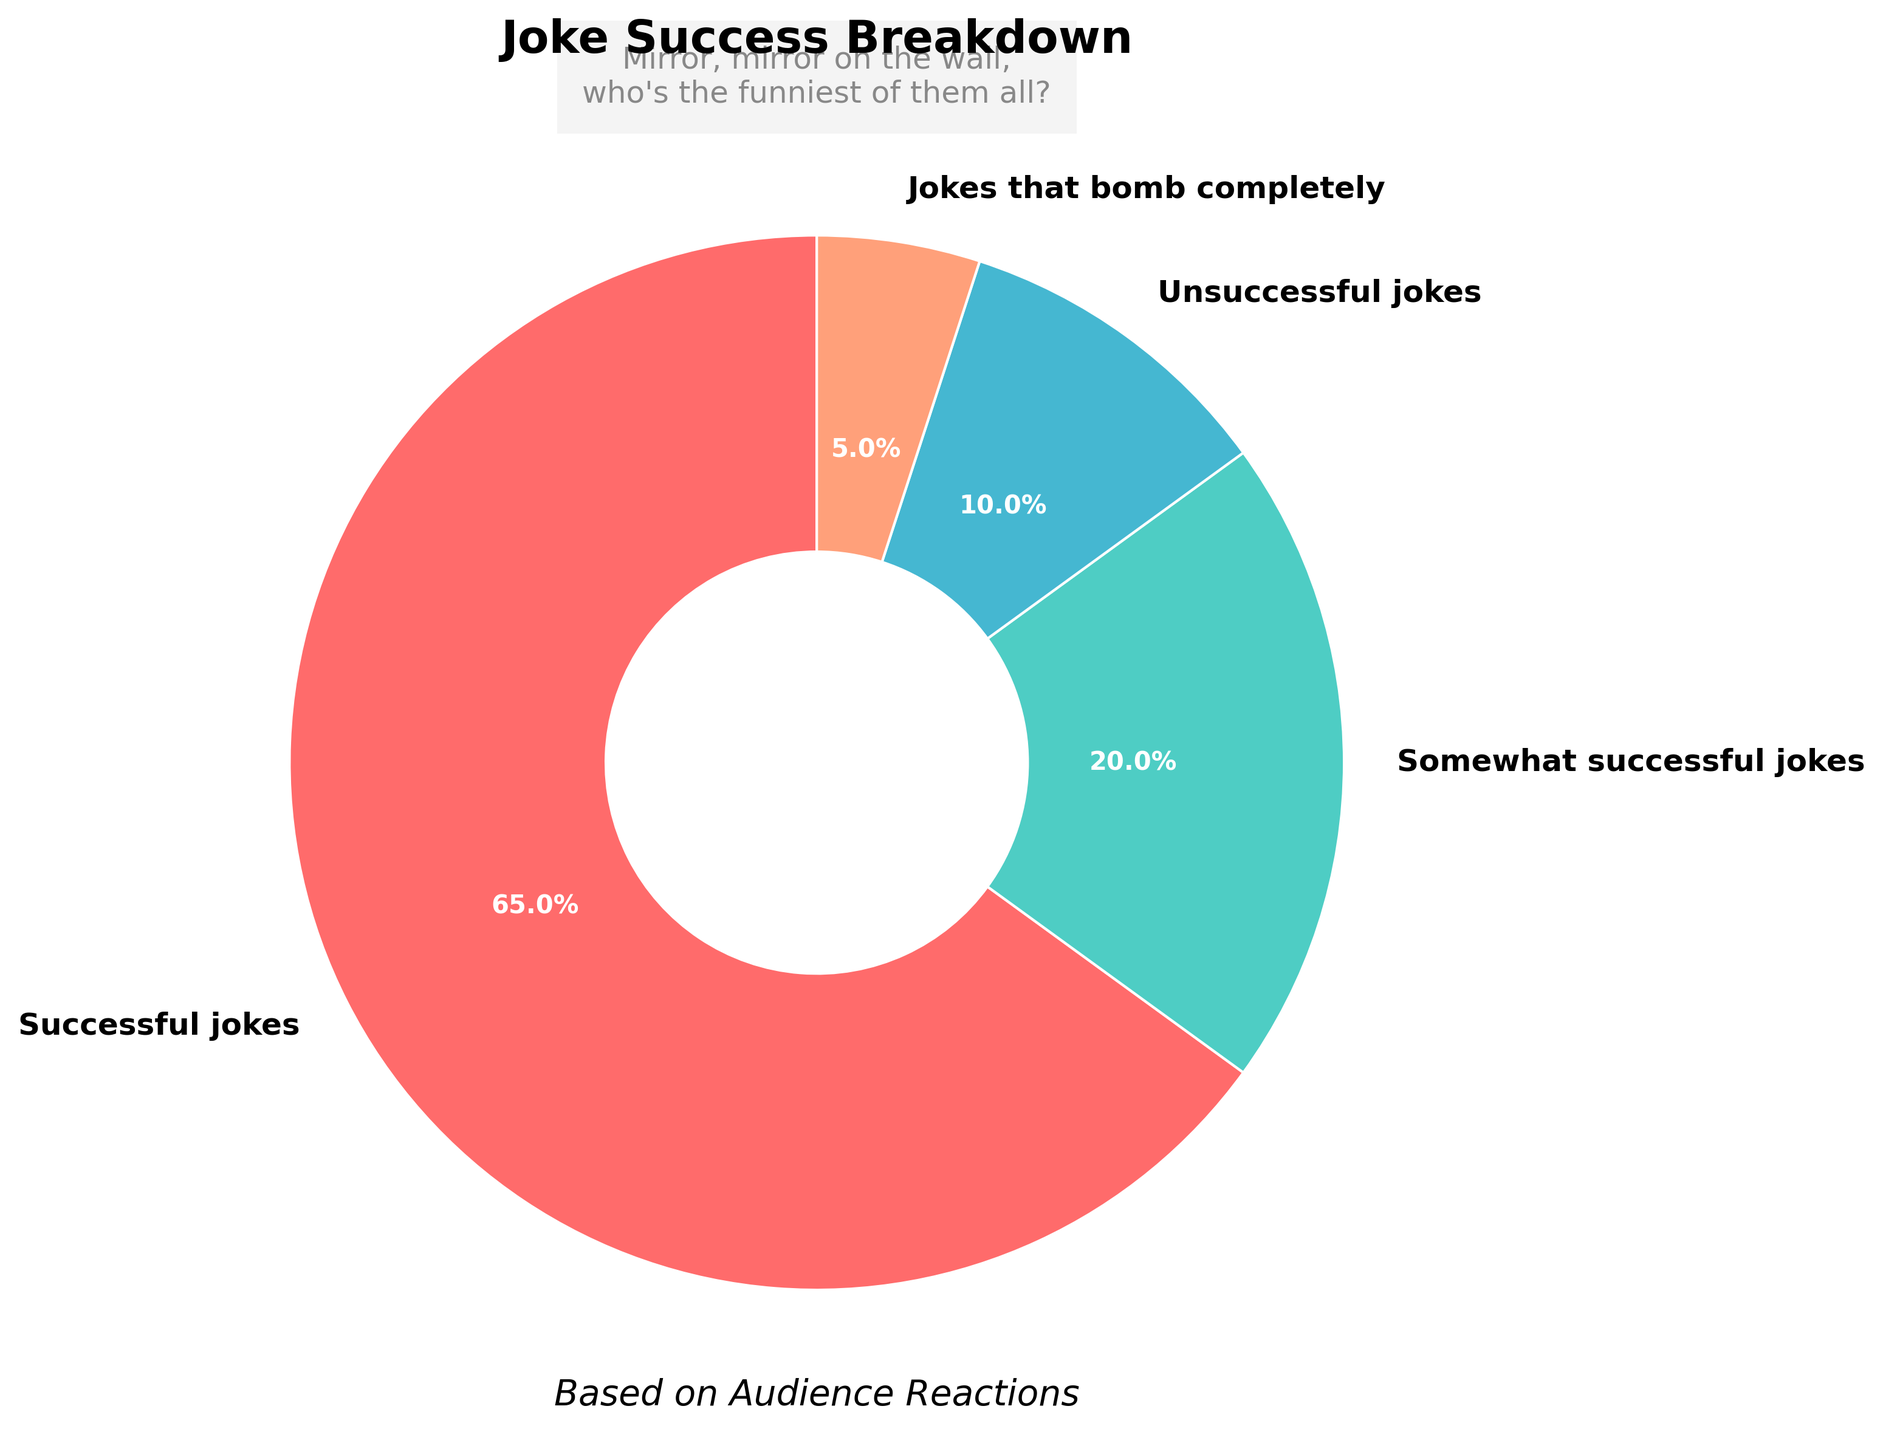which category has the highest percentage of jokes? The pie chart shows different categories of jokes with percentages. The category with the largest section of the pie is the one with the highest percentage. In this case, the "Successful jokes" section occupies 65% of the chart.
Answer: Successful jokes what is the total percentage of jokes that were not successful? Jokes are divided into "Successful," "Somewhat successful," "Unsuccessful," and "Jokes that bomb completely." Adding the percentages of "Unsuccessful jokes" (10%) and "Jokes that bomb completely" (5%) gives us the total percentage of jokes that were not successful: 10% + 5% = 15%.
Answer: 15% how much larger is the percentage of successful jokes compared to somewhat successful jokes? The percentage of "Successful jokes" is 65% and "Somewhat successful jokes" is 20%. To find how much larger the percentage of successful jokes is, we subtract the somewhat successful percentage from the successful percentage: 65% - 20% = 45%.
Answer: 45% if the percentage of somewhat successful jokes doubled, what would it be? The current percentage of "Somewhat successful jokes" is 20%. If this value doubled, we would multiply it by 2: 20% * 2 = 40%.
Answer: 40% which category occupies the smallest portion of the pie chart? By looking at the pie chart, the smallest section represents the category with the lowest percentage. Here, the "Jokes that bomb completely" section is the smallest, at 5%.
Answer: Jokes that bomb completely are successful jokes more than triple the percentage of jokes that bomb completely? The percentage of successful jokes is 65% and the percentage of jokes that bomb completely is 5%. To check if the successful jokes are more than triple, we calculate 3 times the jokes that bomb completely: 3 * 5% = 15%. Since 65% is greater than 15%, successful jokes are indeed more than triple.
Answer: Yes what percentage did somewhat successful jokes and jokes that bomb completely add to? To find the combined percentage of "Somewhat successful jokes" and "Jokes that bomb completely," we add their respective percentages: 20% + 5% = 25%.
Answer: 25% what is the combined percentage of all categories represented in the pie chart? Adding all the percentages of the categories ("Successful jokes," "Somewhat successful jokes," "Unsuccessful jokes," "Jokes that bomb completely") should sum up to 100%: 65% + 20% + 10% + 5% = 100%.
Answer: 100% which color represents the successful jokes in the pie chart? The pie chart uses different colors for each category. The "Successful jokes" section is shown with a particular color, which can be identified visually. In this case, it is the part colored in red.
Answer: Red 